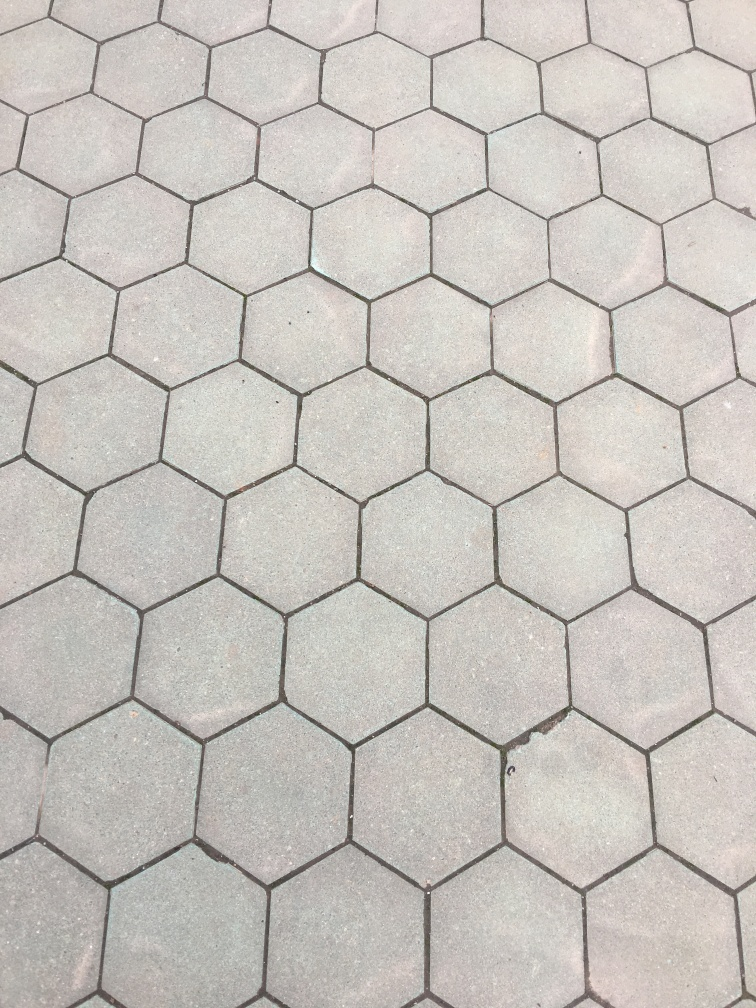What might this image tell us about the location it was taken in? The clean lines and uniformity suggest a well-maintained urban area. The materials and pattern might indicate a contemporary neighborhood where design plays a significant role in the community's infrastructure and aesthetic. 